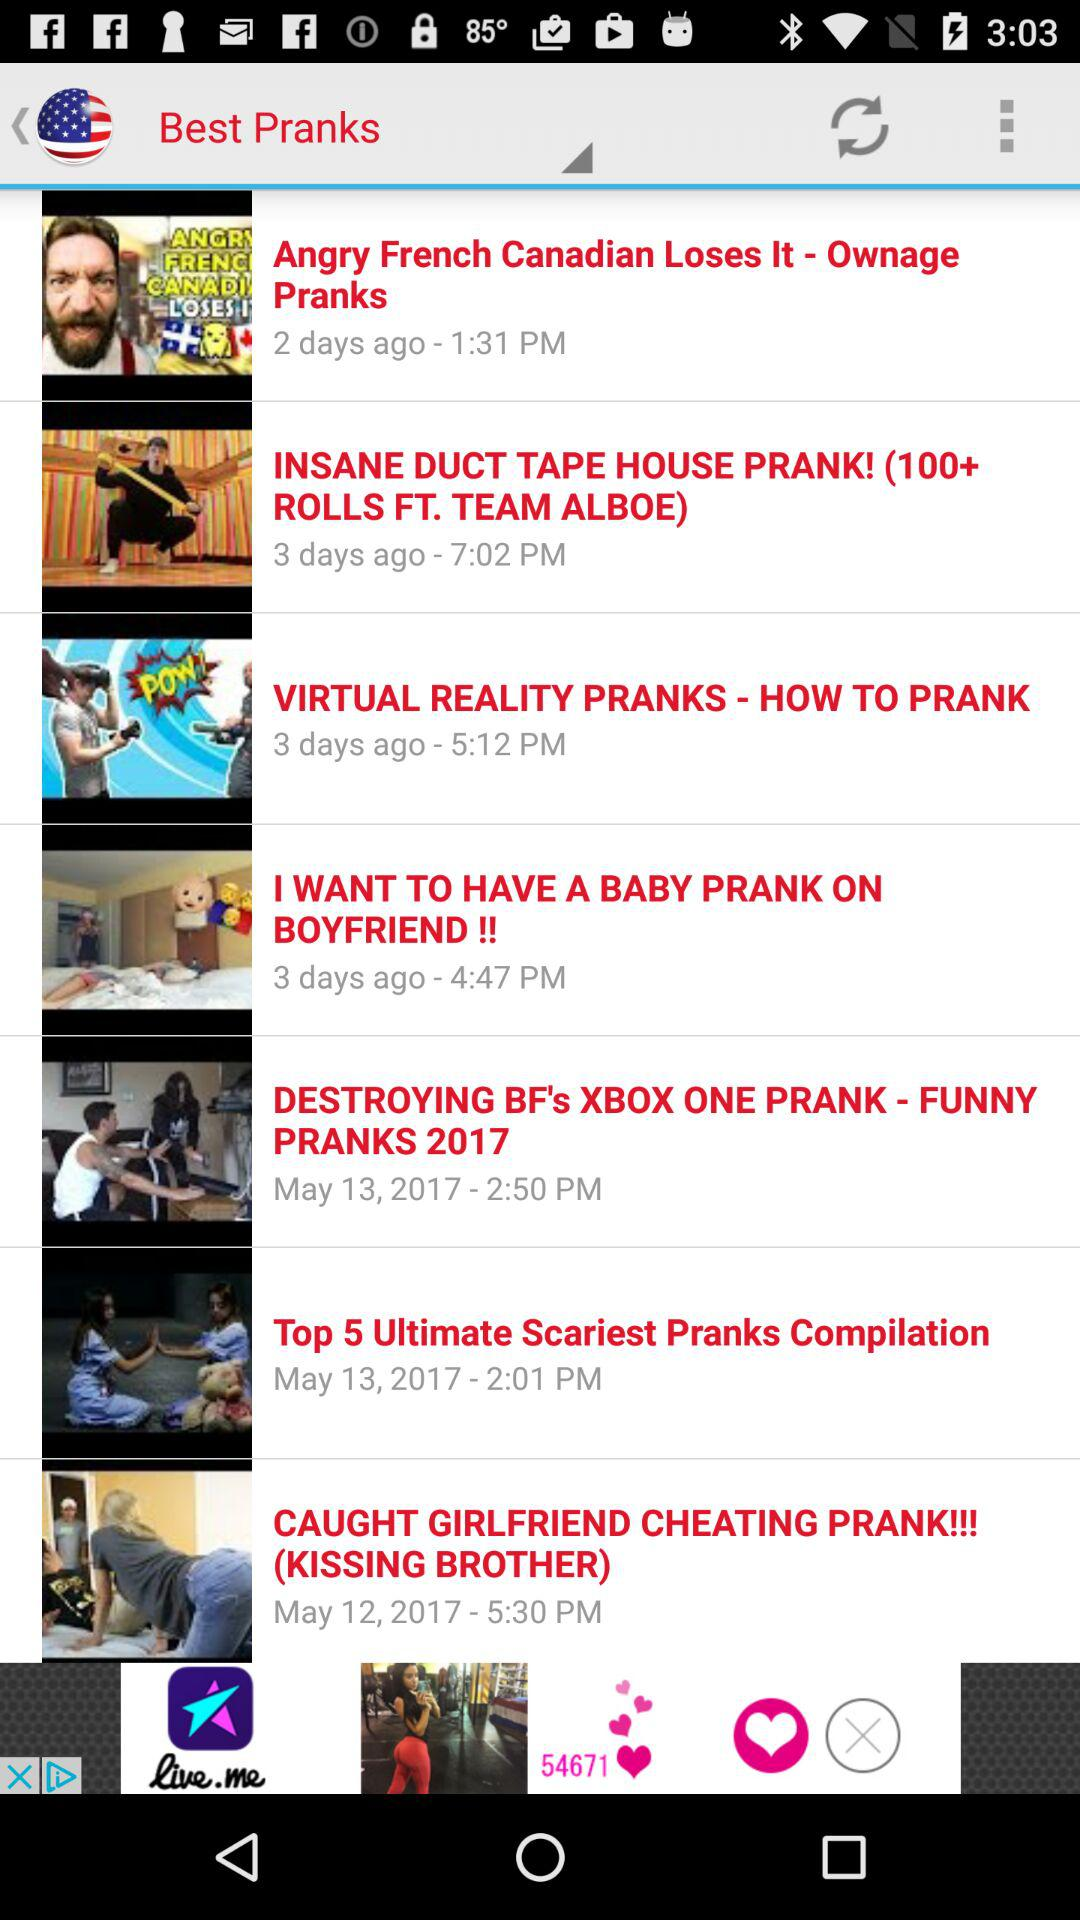How many days ago was "I WANT TO HAVE A BABY PRANK ON BOYFRIEND" posted? It was posted 3 days ago. 